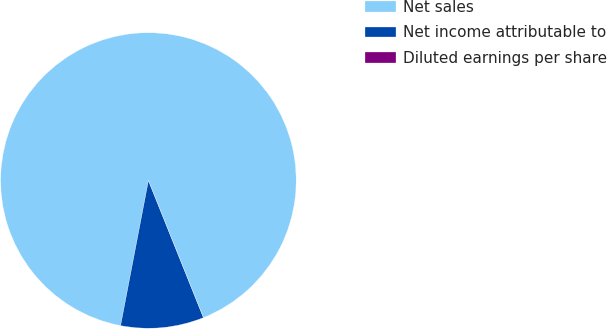Convert chart. <chart><loc_0><loc_0><loc_500><loc_500><pie_chart><fcel>Net sales<fcel>Net income attributable to<fcel>Diluted earnings per share<nl><fcel>90.91%<fcel>9.09%<fcel>0.0%<nl></chart> 